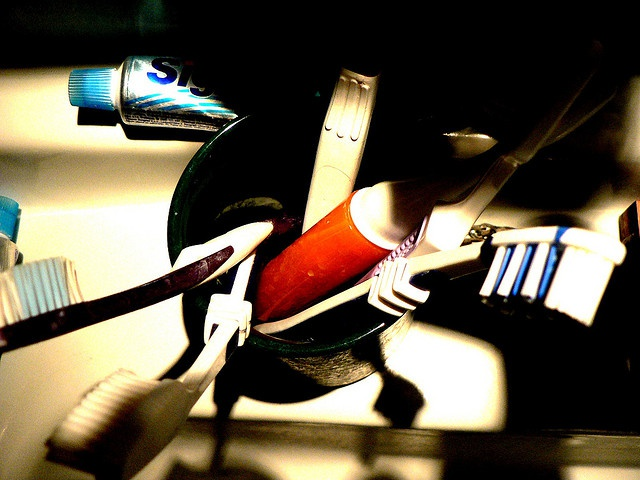Describe the objects in this image and their specific colors. I can see cup in black, ivory, olive, and khaki tones, toothbrush in black, ivory, khaki, and tan tones, toothbrush in black, ivory, khaki, and olive tones, toothbrush in black, red, maroon, and ivory tones, and toothbrush in black, ivory, khaki, and darkgray tones in this image. 